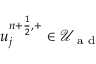<formula> <loc_0><loc_0><loc_500><loc_500>u _ { j } ^ { n + \frac { 1 } { 2 } , + } \in \mathcal { U } _ { a d }</formula> 